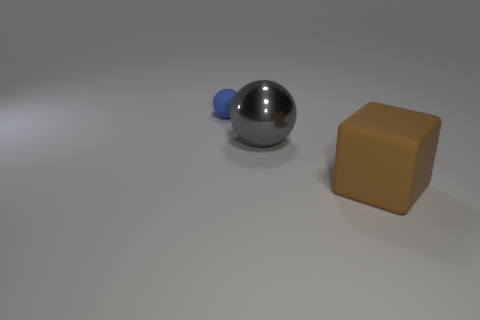The object that is right of the small thing and to the left of the brown cube has what shape?
Ensure brevity in your answer.  Sphere. Are any large brown metallic cylinders visible?
Make the answer very short. No. There is a large thing that is the same shape as the tiny matte object; what material is it?
Offer a terse response. Metal. There is a rubber object in front of the large object behind the big thing to the right of the shiny object; what shape is it?
Offer a terse response. Cube. How many other big metallic things have the same shape as the big brown object?
Your answer should be very brief. 0. There is another thing that is the same size as the brown rubber thing; what is its material?
Give a very brief answer. Metal. Are there any brown rubber things of the same size as the metallic thing?
Keep it short and to the point. Yes. Are there fewer gray shiny things that are behind the tiny matte sphere than big gray metallic objects?
Your answer should be very brief. Yes. Are there fewer gray shiny things behind the big ball than big shiny balls that are left of the brown cube?
Offer a terse response. Yes. How many blocks are large gray metal objects or large objects?
Your answer should be compact. 1. 